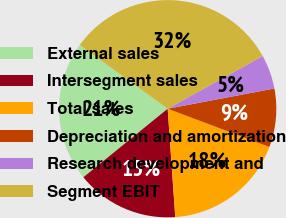<chart> <loc_0><loc_0><loc_500><loc_500><pie_chart><fcel>External sales<fcel>Intersegment sales<fcel>Total sales<fcel>Depreciation and amortization<fcel>Research development and<fcel>Segment EBIT<nl><fcel>20.84%<fcel>15.25%<fcel>18.16%<fcel>8.71%<fcel>5.08%<fcel>31.95%<nl></chart> 